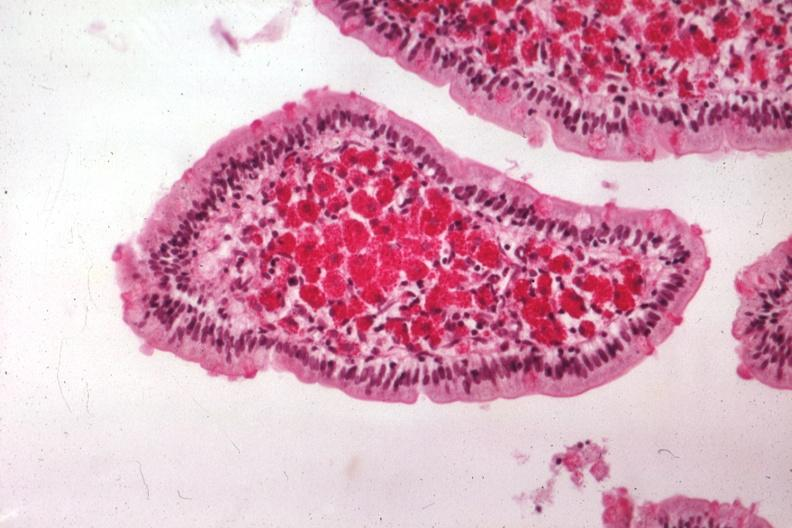where is this from?
Answer the question using a single word or phrase. Gastrointestinal system 